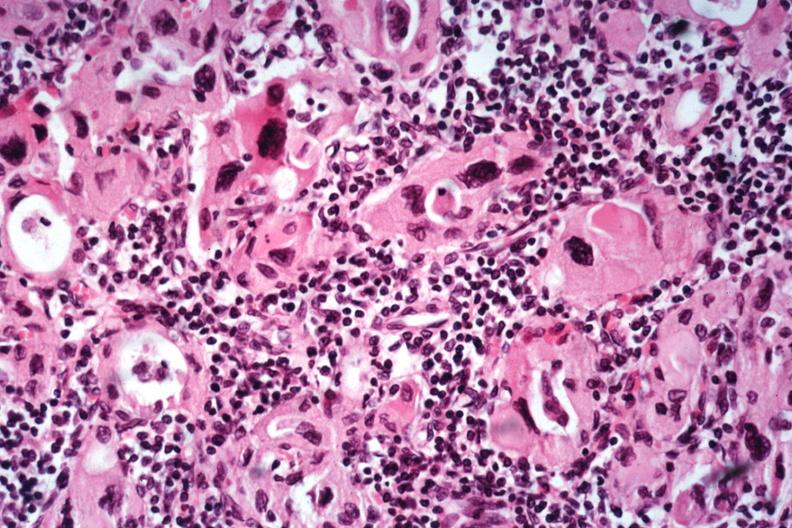s yo present?
Answer the question using a single word or phrase. No 